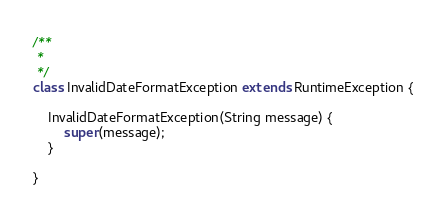Convert code to text. <code><loc_0><loc_0><loc_500><loc_500><_Java_>/**
 *
 */
class InvalidDateFormatException extends RuntimeException {

    InvalidDateFormatException(String message) {
        super(message);
    }

}
</code> 